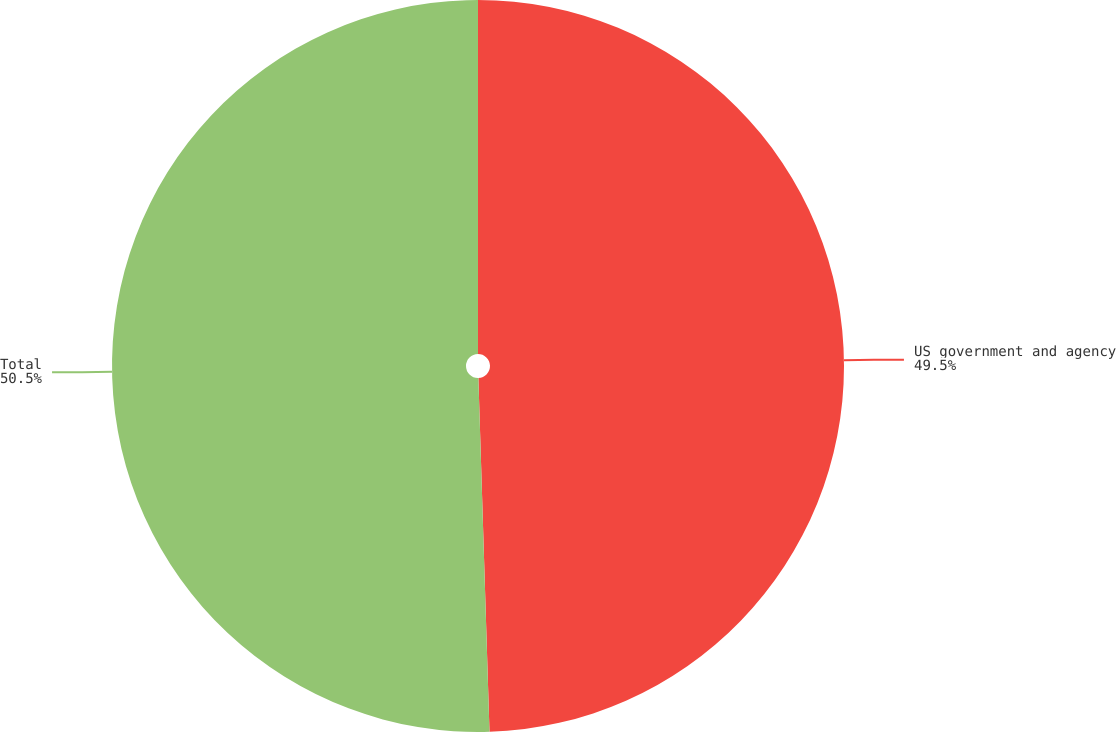Convert chart. <chart><loc_0><loc_0><loc_500><loc_500><pie_chart><fcel>US government and agency<fcel>Total<nl><fcel>49.5%<fcel>50.5%<nl></chart> 